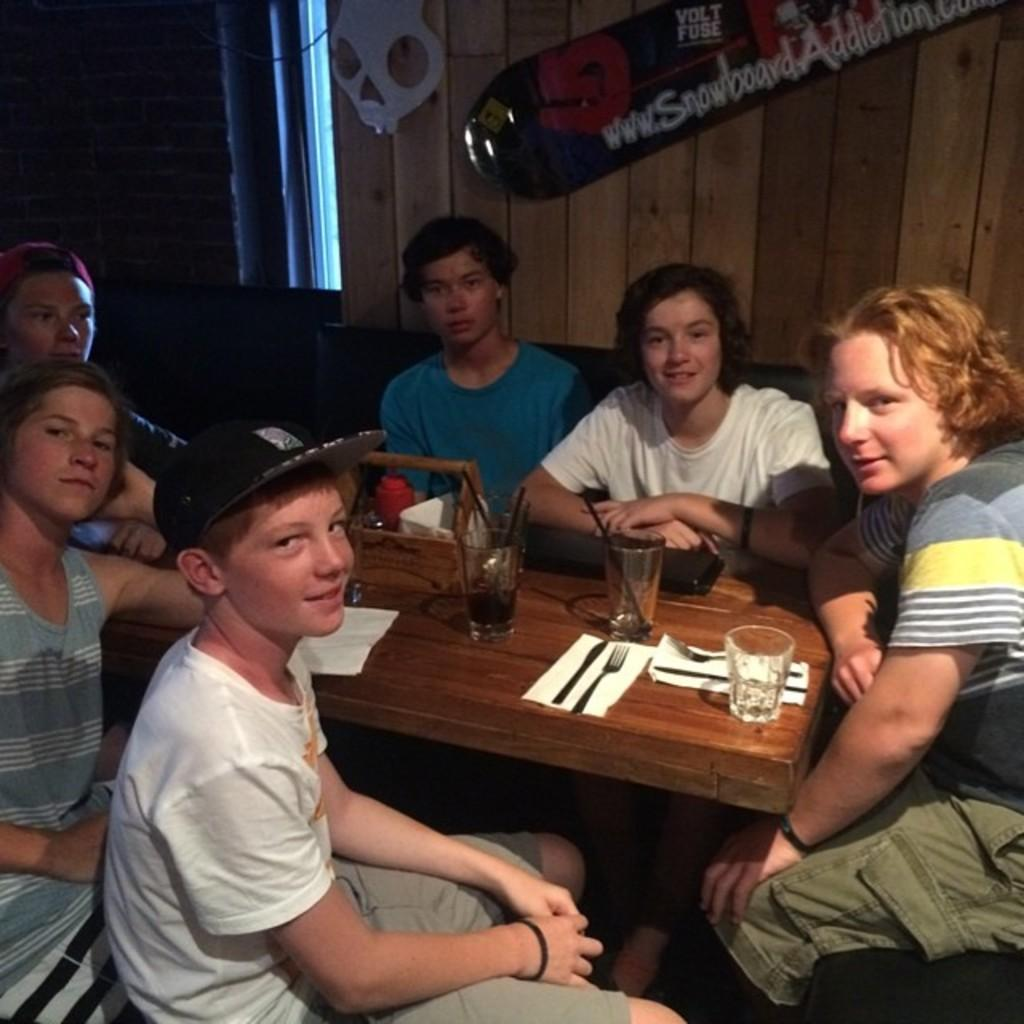How many people are in the image? There is a group of people in the image. What are the people doing in the image? The people are sitting around a table. What items can be seen on the table? There are three glasses, forks, and knives on the table. What can be seen in the background of the image? There is a wooden wall in the background of the image. What type of reward is being given to the people in the image? There is no indication of a reward being given in the image; the people are simply sitting around a table. 